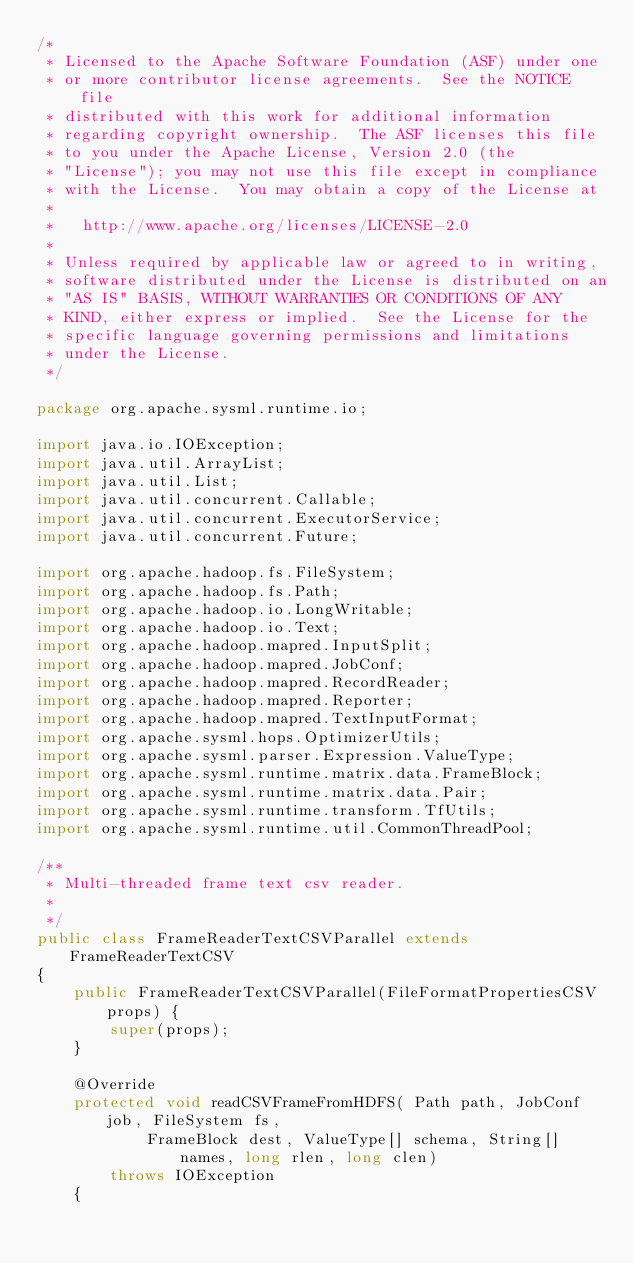<code> <loc_0><loc_0><loc_500><loc_500><_Java_>/*
 * Licensed to the Apache Software Foundation (ASF) under one
 * or more contributor license agreements.  See the NOTICE file
 * distributed with this work for additional information
 * regarding copyright ownership.  The ASF licenses this file
 * to you under the Apache License, Version 2.0 (the
 * "License"); you may not use this file except in compliance
 * with the License.  You may obtain a copy of the License at
 * 
 *   http://www.apache.org/licenses/LICENSE-2.0
 * 
 * Unless required by applicable law or agreed to in writing,
 * software distributed under the License is distributed on an
 * "AS IS" BASIS, WITHOUT WARRANTIES OR CONDITIONS OF ANY
 * KIND, either express or implied.  See the License for the
 * specific language governing permissions and limitations
 * under the License.
 */

package org.apache.sysml.runtime.io;

import java.io.IOException;
import java.util.ArrayList;
import java.util.List;
import java.util.concurrent.Callable;
import java.util.concurrent.ExecutorService;
import java.util.concurrent.Future;

import org.apache.hadoop.fs.FileSystem;
import org.apache.hadoop.fs.Path;
import org.apache.hadoop.io.LongWritable;
import org.apache.hadoop.io.Text;
import org.apache.hadoop.mapred.InputSplit;
import org.apache.hadoop.mapred.JobConf;
import org.apache.hadoop.mapred.RecordReader;
import org.apache.hadoop.mapred.Reporter;
import org.apache.hadoop.mapred.TextInputFormat;
import org.apache.sysml.hops.OptimizerUtils;
import org.apache.sysml.parser.Expression.ValueType;
import org.apache.sysml.runtime.matrix.data.FrameBlock;
import org.apache.sysml.runtime.matrix.data.Pair;
import org.apache.sysml.runtime.transform.TfUtils;
import org.apache.sysml.runtime.util.CommonThreadPool;

/**
 * Multi-threaded frame text csv reader.
 * 
 */
public class FrameReaderTextCSVParallel extends FrameReaderTextCSV
{
	public FrameReaderTextCSVParallel(FileFormatPropertiesCSV props) {
		super(props);
	}

	@Override
	protected void readCSVFrameFromHDFS( Path path, JobConf job, FileSystem fs, 
			FrameBlock dest, ValueType[] schema, String[] names, long rlen, long clen) 
		throws IOException
	{</code> 